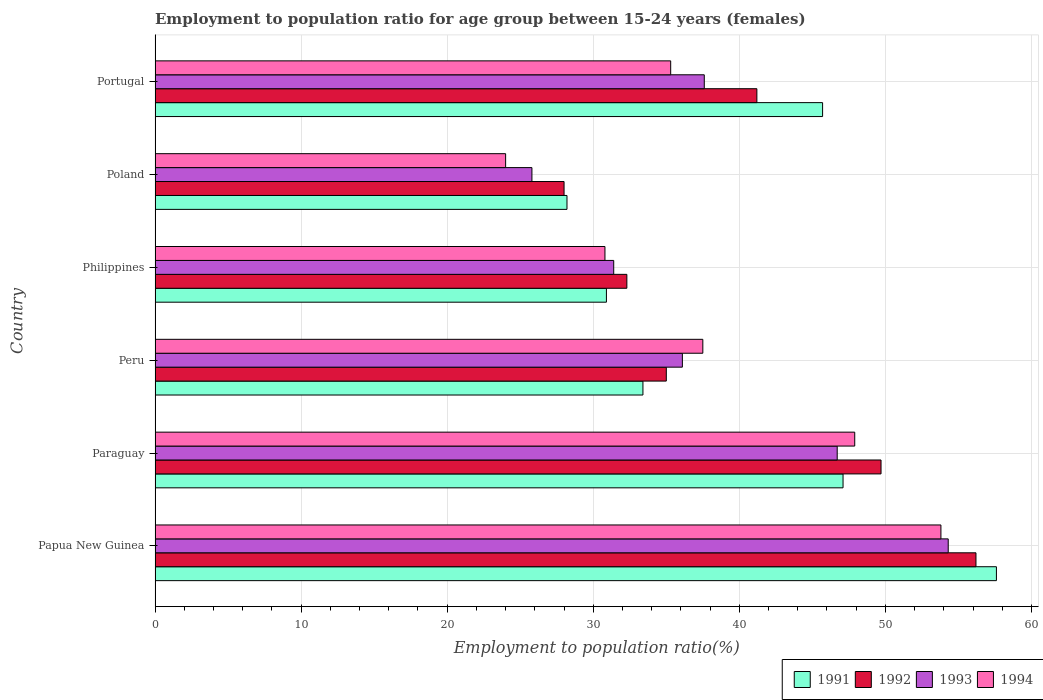How many different coloured bars are there?
Your answer should be very brief. 4. How many bars are there on the 2nd tick from the bottom?
Provide a short and direct response. 4. What is the label of the 6th group of bars from the top?
Offer a terse response. Papua New Guinea. What is the employment to population ratio in 1992 in Paraguay?
Offer a very short reply. 49.7. Across all countries, what is the maximum employment to population ratio in 1993?
Make the answer very short. 54.3. In which country was the employment to population ratio in 1991 maximum?
Offer a very short reply. Papua New Guinea. In which country was the employment to population ratio in 1994 minimum?
Offer a terse response. Poland. What is the total employment to population ratio in 1993 in the graph?
Provide a succinct answer. 231.9. What is the difference between the employment to population ratio in 1994 in Peru and that in Philippines?
Your response must be concise. 6.7. What is the difference between the employment to population ratio in 1993 in Portugal and the employment to population ratio in 1994 in Paraguay?
Your answer should be very brief. -10.3. What is the average employment to population ratio in 1991 per country?
Offer a very short reply. 40.48. What is the difference between the employment to population ratio in 1992 and employment to population ratio in 1994 in Philippines?
Your answer should be very brief. 1.5. In how many countries, is the employment to population ratio in 1992 greater than 6 %?
Ensure brevity in your answer.  6. What is the ratio of the employment to population ratio in 1993 in Philippines to that in Portugal?
Your response must be concise. 0.84. Is the employment to population ratio in 1991 in Papua New Guinea less than that in Peru?
Offer a terse response. No. Is the difference between the employment to population ratio in 1992 in Paraguay and Portugal greater than the difference between the employment to population ratio in 1994 in Paraguay and Portugal?
Keep it short and to the point. No. What is the difference between the highest and the second highest employment to population ratio in 1994?
Provide a succinct answer. 5.9. What is the difference between the highest and the lowest employment to population ratio in 1993?
Give a very brief answer. 28.5. Is the sum of the employment to population ratio in 1992 in Peru and Portugal greater than the maximum employment to population ratio in 1991 across all countries?
Offer a very short reply. Yes. What does the 1st bar from the top in Paraguay represents?
Make the answer very short. 1994. What does the 2nd bar from the bottom in Poland represents?
Offer a very short reply. 1992. Is it the case that in every country, the sum of the employment to population ratio in 1993 and employment to population ratio in 1991 is greater than the employment to population ratio in 1992?
Your answer should be very brief. Yes. Are all the bars in the graph horizontal?
Give a very brief answer. Yes. What is the difference between two consecutive major ticks on the X-axis?
Your answer should be very brief. 10. Does the graph contain any zero values?
Your response must be concise. No. Does the graph contain grids?
Your answer should be very brief. Yes. How many legend labels are there?
Give a very brief answer. 4. How are the legend labels stacked?
Your answer should be compact. Horizontal. What is the title of the graph?
Keep it short and to the point. Employment to population ratio for age group between 15-24 years (females). What is the Employment to population ratio(%) in 1991 in Papua New Guinea?
Ensure brevity in your answer.  57.6. What is the Employment to population ratio(%) in 1992 in Papua New Guinea?
Your response must be concise. 56.2. What is the Employment to population ratio(%) of 1993 in Papua New Guinea?
Your answer should be very brief. 54.3. What is the Employment to population ratio(%) in 1994 in Papua New Guinea?
Your answer should be compact. 53.8. What is the Employment to population ratio(%) of 1991 in Paraguay?
Your response must be concise. 47.1. What is the Employment to population ratio(%) in 1992 in Paraguay?
Your answer should be compact. 49.7. What is the Employment to population ratio(%) of 1993 in Paraguay?
Provide a short and direct response. 46.7. What is the Employment to population ratio(%) of 1994 in Paraguay?
Your answer should be very brief. 47.9. What is the Employment to population ratio(%) of 1991 in Peru?
Offer a very short reply. 33.4. What is the Employment to population ratio(%) of 1992 in Peru?
Your response must be concise. 35. What is the Employment to population ratio(%) of 1993 in Peru?
Your answer should be compact. 36.1. What is the Employment to population ratio(%) of 1994 in Peru?
Make the answer very short. 37.5. What is the Employment to population ratio(%) in 1991 in Philippines?
Give a very brief answer. 30.9. What is the Employment to population ratio(%) of 1992 in Philippines?
Give a very brief answer. 32.3. What is the Employment to population ratio(%) in 1993 in Philippines?
Give a very brief answer. 31.4. What is the Employment to population ratio(%) of 1994 in Philippines?
Provide a succinct answer. 30.8. What is the Employment to population ratio(%) in 1991 in Poland?
Offer a terse response. 28.2. What is the Employment to population ratio(%) in 1992 in Poland?
Offer a terse response. 28. What is the Employment to population ratio(%) of 1993 in Poland?
Give a very brief answer. 25.8. What is the Employment to population ratio(%) of 1991 in Portugal?
Provide a short and direct response. 45.7. What is the Employment to population ratio(%) in 1992 in Portugal?
Provide a short and direct response. 41.2. What is the Employment to population ratio(%) in 1993 in Portugal?
Your response must be concise. 37.6. What is the Employment to population ratio(%) of 1994 in Portugal?
Give a very brief answer. 35.3. Across all countries, what is the maximum Employment to population ratio(%) in 1991?
Give a very brief answer. 57.6. Across all countries, what is the maximum Employment to population ratio(%) in 1992?
Your answer should be very brief. 56.2. Across all countries, what is the maximum Employment to population ratio(%) of 1993?
Keep it short and to the point. 54.3. Across all countries, what is the maximum Employment to population ratio(%) of 1994?
Offer a terse response. 53.8. Across all countries, what is the minimum Employment to population ratio(%) of 1991?
Keep it short and to the point. 28.2. Across all countries, what is the minimum Employment to population ratio(%) in 1993?
Keep it short and to the point. 25.8. Across all countries, what is the minimum Employment to population ratio(%) in 1994?
Ensure brevity in your answer.  24. What is the total Employment to population ratio(%) of 1991 in the graph?
Provide a succinct answer. 242.9. What is the total Employment to population ratio(%) of 1992 in the graph?
Offer a very short reply. 242.4. What is the total Employment to population ratio(%) of 1993 in the graph?
Keep it short and to the point. 231.9. What is the total Employment to population ratio(%) in 1994 in the graph?
Give a very brief answer. 229.3. What is the difference between the Employment to population ratio(%) of 1993 in Papua New Guinea and that in Paraguay?
Provide a short and direct response. 7.6. What is the difference between the Employment to population ratio(%) of 1994 in Papua New Guinea and that in Paraguay?
Offer a very short reply. 5.9. What is the difference between the Employment to population ratio(%) of 1991 in Papua New Guinea and that in Peru?
Your answer should be compact. 24.2. What is the difference between the Employment to population ratio(%) in 1992 in Papua New Guinea and that in Peru?
Provide a short and direct response. 21.2. What is the difference between the Employment to population ratio(%) of 1993 in Papua New Guinea and that in Peru?
Make the answer very short. 18.2. What is the difference between the Employment to population ratio(%) in 1994 in Papua New Guinea and that in Peru?
Your response must be concise. 16.3. What is the difference between the Employment to population ratio(%) of 1991 in Papua New Guinea and that in Philippines?
Give a very brief answer. 26.7. What is the difference between the Employment to population ratio(%) of 1992 in Papua New Guinea and that in Philippines?
Your answer should be very brief. 23.9. What is the difference between the Employment to population ratio(%) in 1993 in Papua New Guinea and that in Philippines?
Keep it short and to the point. 22.9. What is the difference between the Employment to population ratio(%) in 1991 in Papua New Guinea and that in Poland?
Your answer should be compact. 29.4. What is the difference between the Employment to population ratio(%) in 1992 in Papua New Guinea and that in Poland?
Make the answer very short. 28.2. What is the difference between the Employment to population ratio(%) in 1994 in Papua New Guinea and that in Poland?
Your response must be concise. 29.8. What is the difference between the Employment to population ratio(%) of 1991 in Papua New Guinea and that in Portugal?
Ensure brevity in your answer.  11.9. What is the difference between the Employment to population ratio(%) of 1993 in Papua New Guinea and that in Portugal?
Provide a short and direct response. 16.7. What is the difference between the Employment to population ratio(%) in 1994 in Papua New Guinea and that in Portugal?
Provide a short and direct response. 18.5. What is the difference between the Employment to population ratio(%) of 1993 in Paraguay and that in Peru?
Make the answer very short. 10.6. What is the difference between the Employment to population ratio(%) of 1994 in Paraguay and that in Peru?
Your answer should be very brief. 10.4. What is the difference between the Employment to population ratio(%) in 1992 in Paraguay and that in Philippines?
Your response must be concise. 17.4. What is the difference between the Employment to population ratio(%) of 1994 in Paraguay and that in Philippines?
Keep it short and to the point. 17.1. What is the difference between the Employment to population ratio(%) of 1991 in Paraguay and that in Poland?
Provide a short and direct response. 18.9. What is the difference between the Employment to population ratio(%) of 1992 in Paraguay and that in Poland?
Your answer should be compact. 21.7. What is the difference between the Employment to population ratio(%) of 1993 in Paraguay and that in Poland?
Your answer should be compact. 20.9. What is the difference between the Employment to population ratio(%) of 1994 in Paraguay and that in Poland?
Give a very brief answer. 23.9. What is the difference between the Employment to population ratio(%) in 1993 in Paraguay and that in Portugal?
Give a very brief answer. 9.1. What is the difference between the Employment to population ratio(%) in 1994 in Paraguay and that in Portugal?
Your response must be concise. 12.6. What is the difference between the Employment to population ratio(%) in 1991 in Peru and that in Philippines?
Your answer should be very brief. 2.5. What is the difference between the Employment to population ratio(%) of 1993 in Peru and that in Philippines?
Your answer should be very brief. 4.7. What is the difference between the Employment to population ratio(%) in 1994 in Peru and that in Philippines?
Make the answer very short. 6.7. What is the difference between the Employment to population ratio(%) in 1991 in Peru and that in Poland?
Ensure brevity in your answer.  5.2. What is the difference between the Employment to population ratio(%) in 1992 in Peru and that in Poland?
Your response must be concise. 7. What is the difference between the Employment to population ratio(%) in 1994 in Peru and that in Poland?
Make the answer very short. 13.5. What is the difference between the Employment to population ratio(%) in 1994 in Peru and that in Portugal?
Your answer should be very brief. 2.2. What is the difference between the Employment to population ratio(%) in 1991 in Philippines and that in Poland?
Provide a succinct answer. 2.7. What is the difference between the Employment to population ratio(%) in 1991 in Philippines and that in Portugal?
Your answer should be very brief. -14.8. What is the difference between the Employment to population ratio(%) in 1992 in Philippines and that in Portugal?
Offer a terse response. -8.9. What is the difference between the Employment to population ratio(%) of 1991 in Poland and that in Portugal?
Make the answer very short. -17.5. What is the difference between the Employment to population ratio(%) of 1992 in Poland and that in Portugal?
Make the answer very short. -13.2. What is the difference between the Employment to population ratio(%) of 1994 in Poland and that in Portugal?
Your response must be concise. -11.3. What is the difference between the Employment to population ratio(%) in 1991 in Papua New Guinea and the Employment to population ratio(%) in 1993 in Paraguay?
Keep it short and to the point. 10.9. What is the difference between the Employment to population ratio(%) in 1991 in Papua New Guinea and the Employment to population ratio(%) in 1994 in Paraguay?
Provide a short and direct response. 9.7. What is the difference between the Employment to population ratio(%) in 1992 in Papua New Guinea and the Employment to population ratio(%) in 1993 in Paraguay?
Your response must be concise. 9.5. What is the difference between the Employment to population ratio(%) of 1992 in Papua New Guinea and the Employment to population ratio(%) of 1994 in Paraguay?
Make the answer very short. 8.3. What is the difference between the Employment to population ratio(%) of 1991 in Papua New Guinea and the Employment to population ratio(%) of 1992 in Peru?
Make the answer very short. 22.6. What is the difference between the Employment to population ratio(%) in 1991 in Papua New Guinea and the Employment to population ratio(%) in 1994 in Peru?
Make the answer very short. 20.1. What is the difference between the Employment to population ratio(%) of 1992 in Papua New Guinea and the Employment to population ratio(%) of 1993 in Peru?
Provide a short and direct response. 20.1. What is the difference between the Employment to population ratio(%) in 1991 in Papua New Guinea and the Employment to population ratio(%) in 1992 in Philippines?
Keep it short and to the point. 25.3. What is the difference between the Employment to population ratio(%) in 1991 in Papua New Guinea and the Employment to population ratio(%) in 1993 in Philippines?
Give a very brief answer. 26.2. What is the difference between the Employment to population ratio(%) of 1991 in Papua New Guinea and the Employment to population ratio(%) of 1994 in Philippines?
Offer a terse response. 26.8. What is the difference between the Employment to population ratio(%) of 1992 in Papua New Guinea and the Employment to population ratio(%) of 1993 in Philippines?
Ensure brevity in your answer.  24.8. What is the difference between the Employment to population ratio(%) of 1992 in Papua New Guinea and the Employment to population ratio(%) of 1994 in Philippines?
Offer a very short reply. 25.4. What is the difference between the Employment to population ratio(%) of 1993 in Papua New Guinea and the Employment to population ratio(%) of 1994 in Philippines?
Your answer should be very brief. 23.5. What is the difference between the Employment to population ratio(%) of 1991 in Papua New Guinea and the Employment to population ratio(%) of 1992 in Poland?
Provide a short and direct response. 29.6. What is the difference between the Employment to population ratio(%) in 1991 in Papua New Guinea and the Employment to population ratio(%) in 1993 in Poland?
Your response must be concise. 31.8. What is the difference between the Employment to population ratio(%) of 1991 in Papua New Guinea and the Employment to population ratio(%) of 1994 in Poland?
Your response must be concise. 33.6. What is the difference between the Employment to population ratio(%) in 1992 in Papua New Guinea and the Employment to population ratio(%) in 1993 in Poland?
Offer a very short reply. 30.4. What is the difference between the Employment to population ratio(%) of 1992 in Papua New Guinea and the Employment to population ratio(%) of 1994 in Poland?
Offer a very short reply. 32.2. What is the difference between the Employment to population ratio(%) in 1993 in Papua New Guinea and the Employment to population ratio(%) in 1994 in Poland?
Provide a succinct answer. 30.3. What is the difference between the Employment to population ratio(%) in 1991 in Papua New Guinea and the Employment to population ratio(%) in 1992 in Portugal?
Ensure brevity in your answer.  16.4. What is the difference between the Employment to population ratio(%) of 1991 in Papua New Guinea and the Employment to population ratio(%) of 1994 in Portugal?
Give a very brief answer. 22.3. What is the difference between the Employment to population ratio(%) in 1992 in Papua New Guinea and the Employment to population ratio(%) in 1993 in Portugal?
Provide a succinct answer. 18.6. What is the difference between the Employment to population ratio(%) in 1992 in Papua New Guinea and the Employment to population ratio(%) in 1994 in Portugal?
Give a very brief answer. 20.9. What is the difference between the Employment to population ratio(%) in 1993 in Papua New Guinea and the Employment to population ratio(%) in 1994 in Portugal?
Offer a very short reply. 19. What is the difference between the Employment to population ratio(%) in 1991 in Paraguay and the Employment to population ratio(%) in 1992 in Peru?
Offer a very short reply. 12.1. What is the difference between the Employment to population ratio(%) of 1991 in Paraguay and the Employment to population ratio(%) of 1993 in Peru?
Make the answer very short. 11. What is the difference between the Employment to population ratio(%) of 1992 in Paraguay and the Employment to population ratio(%) of 1994 in Peru?
Provide a succinct answer. 12.2. What is the difference between the Employment to population ratio(%) in 1991 in Paraguay and the Employment to population ratio(%) in 1992 in Philippines?
Ensure brevity in your answer.  14.8. What is the difference between the Employment to population ratio(%) of 1991 in Paraguay and the Employment to population ratio(%) of 1993 in Philippines?
Provide a short and direct response. 15.7. What is the difference between the Employment to population ratio(%) in 1991 in Paraguay and the Employment to population ratio(%) in 1994 in Philippines?
Make the answer very short. 16.3. What is the difference between the Employment to population ratio(%) in 1992 in Paraguay and the Employment to population ratio(%) in 1993 in Philippines?
Offer a very short reply. 18.3. What is the difference between the Employment to population ratio(%) of 1993 in Paraguay and the Employment to population ratio(%) of 1994 in Philippines?
Provide a short and direct response. 15.9. What is the difference between the Employment to population ratio(%) in 1991 in Paraguay and the Employment to population ratio(%) in 1992 in Poland?
Keep it short and to the point. 19.1. What is the difference between the Employment to population ratio(%) of 1991 in Paraguay and the Employment to population ratio(%) of 1993 in Poland?
Your response must be concise. 21.3. What is the difference between the Employment to population ratio(%) in 1991 in Paraguay and the Employment to population ratio(%) in 1994 in Poland?
Give a very brief answer. 23.1. What is the difference between the Employment to population ratio(%) in 1992 in Paraguay and the Employment to population ratio(%) in 1993 in Poland?
Offer a terse response. 23.9. What is the difference between the Employment to population ratio(%) in 1992 in Paraguay and the Employment to population ratio(%) in 1994 in Poland?
Offer a very short reply. 25.7. What is the difference between the Employment to population ratio(%) in 1993 in Paraguay and the Employment to population ratio(%) in 1994 in Poland?
Make the answer very short. 22.7. What is the difference between the Employment to population ratio(%) in 1991 in Paraguay and the Employment to population ratio(%) in 1993 in Portugal?
Give a very brief answer. 9.5. What is the difference between the Employment to population ratio(%) of 1992 in Paraguay and the Employment to population ratio(%) of 1993 in Portugal?
Your response must be concise. 12.1. What is the difference between the Employment to population ratio(%) in 1992 in Paraguay and the Employment to population ratio(%) in 1994 in Portugal?
Provide a short and direct response. 14.4. What is the difference between the Employment to population ratio(%) of 1993 in Paraguay and the Employment to population ratio(%) of 1994 in Portugal?
Provide a succinct answer. 11.4. What is the difference between the Employment to population ratio(%) in 1991 in Peru and the Employment to population ratio(%) in 1992 in Philippines?
Your answer should be compact. 1.1. What is the difference between the Employment to population ratio(%) in 1991 in Peru and the Employment to population ratio(%) in 1994 in Philippines?
Offer a very short reply. 2.6. What is the difference between the Employment to population ratio(%) in 1991 in Peru and the Employment to population ratio(%) in 1992 in Poland?
Provide a short and direct response. 5.4. What is the difference between the Employment to population ratio(%) in 1991 in Peru and the Employment to population ratio(%) in 1993 in Poland?
Offer a very short reply. 7.6. What is the difference between the Employment to population ratio(%) in 1991 in Peru and the Employment to population ratio(%) in 1994 in Poland?
Offer a very short reply. 9.4. What is the difference between the Employment to population ratio(%) in 1992 in Peru and the Employment to population ratio(%) in 1993 in Poland?
Give a very brief answer. 9.2. What is the difference between the Employment to population ratio(%) in 1992 in Peru and the Employment to population ratio(%) in 1994 in Poland?
Your answer should be very brief. 11. What is the difference between the Employment to population ratio(%) of 1993 in Peru and the Employment to population ratio(%) of 1994 in Poland?
Offer a very short reply. 12.1. What is the difference between the Employment to population ratio(%) in 1991 in Peru and the Employment to population ratio(%) in 1992 in Portugal?
Your response must be concise. -7.8. What is the difference between the Employment to population ratio(%) of 1991 in Peru and the Employment to population ratio(%) of 1993 in Portugal?
Your answer should be very brief. -4.2. What is the difference between the Employment to population ratio(%) in 1991 in Peru and the Employment to population ratio(%) in 1994 in Portugal?
Your answer should be very brief. -1.9. What is the difference between the Employment to population ratio(%) of 1992 in Peru and the Employment to population ratio(%) of 1993 in Portugal?
Your answer should be compact. -2.6. What is the difference between the Employment to population ratio(%) in 1992 in Peru and the Employment to population ratio(%) in 1994 in Portugal?
Keep it short and to the point. -0.3. What is the difference between the Employment to population ratio(%) of 1993 in Peru and the Employment to population ratio(%) of 1994 in Portugal?
Keep it short and to the point. 0.8. What is the difference between the Employment to population ratio(%) in 1991 in Philippines and the Employment to population ratio(%) in 1992 in Poland?
Your answer should be compact. 2.9. What is the difference between the Employment to population ratio(%) of 1991 in Philippines and the Employment to population ratio(%) of 1994 in Poland?
Offer a very short reply. 6.9. What is the difference between the Employment to population ratio(%) in 1993 in Philippines and the Employment to population ratio(%) in 1994 in Portugal?
Provide a short and direct response. -3.9. What is the difference between the Employment to population ratio(%) in 1992 in Poland and the Employment to population ratio(%) in 1993 in Portugal?
Keep it short and to the point. -9.6. What is the difference between the Employment to population ratio(%) in 1993 in Poland and the Employment to population ratio(%) in 1994 in Portugal?
Keep it short and to the point. -9.5. What is the average Employment to population ratio(%) in 1991 per country?
Provide a succinct answer. 40.48. What is the average Employment to population ratio(%) in 1992 per country?
Your response must be concise. 40.4. What is the average Employment to population ratio(%) in 1993 per country?
Your response must be concise. 38.65. What is the average Employment to population ratio(%) in 1994 per country?
Provide a succinct answer. 38.22. What is the difference between the Employment to population ratio(%) of 1991 and Employment to population ratio(%) of 1994 in Papua New Guinea?
Keep it short and to the point. 3.8. What is the difference between the Employment to population ratio(%) of 1992 and Employment to population ratio(%) of 1993 in Papua New Guinea?
Keep it short and to the point. 1.9. What is the difference between the Employment to population ratio(%) in 1992 and Employment to population ratio(%) in 1994 in Papua New Guinea?
Provide a succinct answer. 2.4. What is the difference between the Employment to population ratio(%) in 1991 and Employment to population ratio(%) in 1992 in Paraguay?
Give a very brief answer. -2.6. What is the difference between the Employment to population ratio(%) in 1991 and Employment to population ratio(%) in 1993 in Paraguay?
Provide a short and direct response. 0.4. What is the difference between the Employment to population ratio(%) in 1992 and Employment to population ratio(%) in 1994 in Paraguay?
Provide a short and direct response. 1.8. What is the difference between the Employment to population ratio(%) of 1991 and Employment to population ratio(%) of 1992 in Peru?
Provide a short and direct response. -1.6. What is the difference between the Employment to population ratio(%) in 1991 and Employment to population ratio(%) in 1994 in Philippines?
Your answer should be compact. 0.1. What is the difference between the Employment to population ratio(%) in 1992 and Employment to population ratio(%) in 1993 in Philippines?
Your answer should be compact. 0.9. What is the difference between the Employment to population ratio(%) of 1992 and Employment to population ratio(%) of 1994 in Philippines?
Keep it short and to the point. 1.5. What is the difference between the Employment to population ratio(%) in 1993 and Employment to population ratio(%) in 1994 in Philippines?
Your answer should be compact. 0.6. What is the difference between the Employment to population ratio(%) in 1991 and Employment to population ratio(%) in 1992 in Poland?
Make the answer very short. 0.2. What is the difference between the Employment to population ratio(%) in 1991 and Employment to population ratio(%) in 1994 in Poland?
Your answer should be compact. 4.2. What is the difference between the Employment to population ratio(%) in 1992 and Employment to population ratio(%) in 1994 in Poland?
Give a very brief answer. 4. What is the difference between the Employment to population ratio(%) in 1991 and Employment to population ratio(%) in 1994 in Portugal?
Ensure brevity in your answer.  10.4. What is the difference between the Employment to population ratio(%) in 1992 and Employment to population ratio(%) in 1993 in Portugal?
Your answer should be compact. 3.6. What is the ratio of the Employment to population ratio(%) in 1991 in Papua New Guinea to that in Paraguay?
Provide a short and direct response. 1.22. What is the ratio of the Employment to population ratio(%) of 1992 in Papua New Guinea to that in Paraguay?
Keep it short and to the point. 1.13. What is the ratio of the Employment to population ratio(%) of 1993 in Papua New Guinea to that in Paraguay?
Offer a terse response. 1.16. What is the ratio of the Employment to population ratio(%) in 1994 in Papua New Guinea to that in Paraguay?
Keep it short and to the point. 1.12. What is the ratio of the Employment to population ratio(%) in 1991 in Papua New Guinea to that in Peru?
Your response must be concise. 1.72. What is the ratio of the Employment to population ratio(%) of 1992 in Papua New Guinea to that in Peru?
Your answer should be compact. 1.61. What is the ratio of the Employment to population ratio(%) of 1993 in Papua New Guinea to that in Peru?
Offer a very short reply. 1.5. What is the ratio of the Employment to population ratio(%) in 1994 in Papua New Guinea to that in Peru?
Keep it short and to the point. 1.43. What is the ratio of the Employment to population ratio(%) in 1991 in Papua New Guinea to that in Philippines?
Provide a succinct answer. 1.86. What is the ratio of the Employment to population ratio(%) in 1992 in Papua New Guinea to that in Philippines?
Ensure brevity in your answer.  1.74. What is the ratio of the Employment to population ratio(%) in 1993 in Papua New Guinea to that in Philippines?
Your response must be concise. 1.73. What is the ratio of the Employment to population ratio(%) in 1994 in Papua New Guinea to that in Philippines?
Ensure brevity in your answer.  1.75. What is the ratio of the Employment to population ratio(%) of 1991 in Papua New Guinea to that in Poland?
Your answer should be very brief. 2.04. What is the ratio of the Employment to population ratio(%) in 1992 in Papua New Guinea to that in Poland?
Your answer should be very brief. 2.01. What is the ratio of the Employment to population ratio(%) in 1993 in Papua New Guinea to that in Poland?
Ensure brevity in your answer.  2.1. What is the ratio of the Employment to population ratio(%) in 1994 in Papua New Guinea to that in Poland?
Keep it short and to the point. 2.24. What is the ratio of the Employment to population ratio(%) in 1991 in Papua New Guinea to that in Portugal?
Give a very brief answer. 1.26. What is the ratio of the Employment to population ratio(%) in 1992 in Papua New Guinea to that in Portugal?
Offer a terse response. 1.36. What is the ratio of the Employment to population ratio(%) in 1993 in Papua New Guinea to that in Portugal?
Your answer should be compact. 1.44. What is the ratio of the Employment to population ratio(%) of 1994 in Papua New Guinea to that in Portugal?
Give a very brief answer. 1.52. What is the ratio of the Employment to population ratio(%) of 1991 in Paraguay to that in Peru?
Offer a terse response. 1.41. What is the ratio of the Employment to population ratio(%) of 1992 in Paraguay to that in Peru?
Give a very brief answer. 1.42. What is the ratio of the Employment to population ratio(%) of 1993 in Paraguay to that in Peru?
Offer a very short reply. 1.29. What is the ratio of the Employment to population ratio(%) of 1994 in Paraguay to that in Peru?
Keep it short and to the point. 1.28. What is the ratio of the Employment to population ratio(%) of 1991 in Paraguay to that in Philippines?
Your response must be concise. 1.52. What is the ratio of the Employment to population ratio(%) of 1992 in Paraguay to that in Philippines?
Your response must be concise. 1.54. What is the ratio of the Employment to population ratio(%) of 1993 in Paraguay to that in Philippines?
Give a very brief answer. 1.49. What is the ratio of the Employment to population ratio(%) of 1994 in Paraguay to that in Philippines?
Make the answer very short. 1.56. What is the ratio of the Employment to population ratio(%) of 1991 in Paraguay to that in Poland?
Make the answer very short. 1.67. What is the ratio of the Employment to population ratio(%) of 1992 in Paraguay to that in Poland?
Your answer should be very brief. 1.77. What is the ratio of the Employment to population ratio(%) of 1993 in Paraguay to that in Poland?
Provide a short and direct response. 1.81. What is the ratio of the Employment to population ratio(%) of 1994 in Paraguay to that in Poland?
Your answer should be compact. 2. What is the ratio of the Employment to population ratio(%) of 1991 in Paraguay to that in Portugal?
Keep it short and to the point. 1.03. What is the ratio of the Employment to population ratio(%) in 1992 in Paraguay to that in Portugal?
Your answer should be compact. 1.21. What is the ratio of the Employment to population ratio(%) of 1993 in Paraguay to that in Portugal?
Your response must be concise. 1.24. What is the ratio of the Employment to population ratio(%) in 1994 in Paraguay to that in Portugal?
Your answer should be compact. 1.36. What is the ratio of the Employment to population ratio(%) in 1991 in Peru to that in Philippines?
Provide a succinct answer. 1.08. What is the ratio of the Employment to population ratio(%) in 1992 in Peru to that in Philippines?
Offer a very short reply. 1.08. What is the ratio of the Employment to population ratio(%) of 1993 in Peru to that in Philippines?
Give a very brief answer. 1.15. What is the ratio of the Employment to population ratio(%) of 1994 in Peru to that in Philippines?
Provide a short and direct response. 1.22. What is the ratio of the Employment to population ratio(%) in 1991 in Peru to that in Poland?
Provide a short and direct response. 1.18. What is the ratio of the Employment to population ratio(%) in 1992 in Peru to that in Poland?
Your answer should be compact. 1.25. What is the ratio of the Employment to population ratio(%) of 1993 in Peru to that in Poland?
Provide a succinct answer. 1.4. What is the ratio of the Employment to population ratio(%) of 1994 in Peru to that in Poland?
Your answer should be very brief. 1.56. What is the ratio of the Employment to population ratio(%) of 1991 in Peru to that in Portugal?
Your answer should be very brief. 0.73. What is the ratio of the Employment to population ratio(%) in 1992 in Peru to that in Portugal?
Keep it short and to the point. 0.85. What is the ratio of the Employment to population ratio(%) in 1993 in Peru to that in Portugal?
Offer a terse response. 0.96. What is the ratio of the Employment to population ratio(%) of 1994 in Peru to that in Portugal?
Make the answer very short. 1.06. What is the ratio of the Employment to population ratio(%) in 1991 in Philippines to that in Poland?
Ensure brevity in your answer.  1.1. What is the ratio of the Employment to population ratio(%) of 1992 in Philippines to that in Poland?
Your answer should be compact. 1.15. What is the ratio of the Employment to population ratio(%) in 1993 in Philippines to that in Poland?
Keep it short and to the point. 1.22. What is the ratio of the Employment to population ratio(%) of 1994 in Philippines to that in Poland?
Keep it short and to the point. 1.28. What is the ratio of the Employment to population ratio(%) of 1991 in Philippines to that in Portugal?
Your answer should be very brief. 0.68. What is the ratio of the Employment to population ratio(%) of 1992 in Philippines to that in Portugal?
Give a very brief answer. 0.78. What is the ratio of the Employment to population ratio(%) of 1993 in Philippines to that in Portugal?
Your answer should be compact. 0.84. What is the ratio of the Employment to population ratio(%) in 1994 in Philippines to that in Portugal?
Offer a terse response. 0.87. What is the ratio of the Employment to population ratio(%) of 1991 in Poland to that in Portugal?
Offer a very short reply. 0.62. What is the ratio of the Employment to population ratio(%) in 1992 in Poland to that in Portugal?
Provide a succinct answer. 0.68. What is the ratio of the Employment to population ratio(%) in 1993 in Poland to that in Portugal?
Provide a short and direct response. 0.69. What is the ratio of the Employment to population ratio(%) of 1994 in Poland to that in Portugal?
Your answer should be very brief. 0.68. What is the difference between the highest and the second highest Employment to population ratio(%) in 1992?
Ensure brevity in your answer.  6.5. What is the difference between the highest and the second highest Employment to population ratio(%) in 1994?
Provide a succinct answer. 5.9. What is the difference between the highest and the lowest Employment to population ratio(%) in 1991?
Give a very brief answer. 29.4. What is the difference between the highest and the lowest Employment to population ratio(%) of 1992?
Offer a very short reply. 28.2. What is the difference between the highest and the lowest Employment to population ratio(%) of 1993?
Provide a succinct answer. 28.5. What is the difference between the highest and the lowest Employment to population ratio(%) of 1994?
Give a very brief answer. 29.8. 